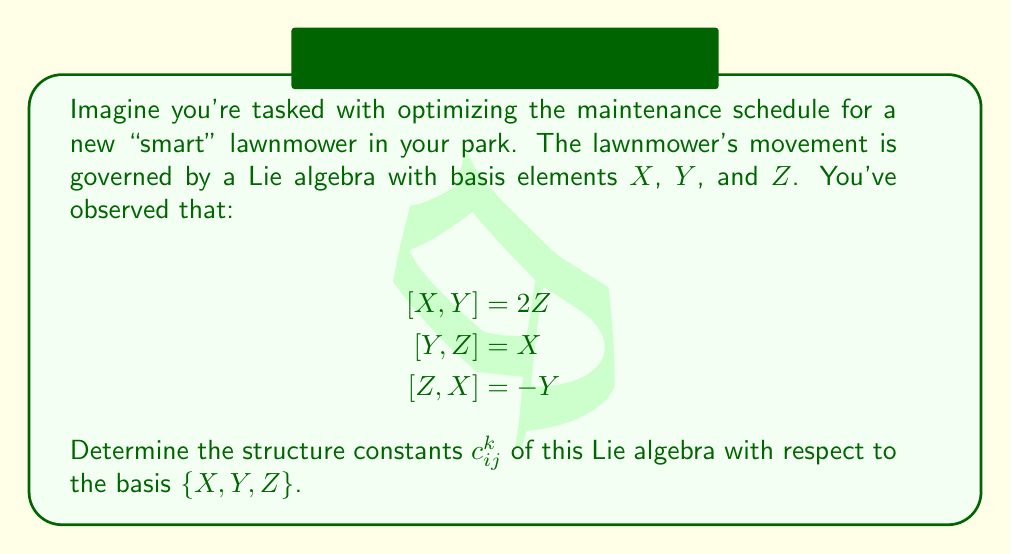Solve this math problem. To find the structure constants $c_{ij}^k$ of a Lie algebra, we need to express each Lie bracket $[X_i,X_j]$ as a linear combination of the basis elements:

$$[X_i,X_j] = \sum_{k} c_{ij}^k X_k$$

In this case, our basis is $\{X,Y,Z\}$, so we'll index them as $X_1 = X$, $X_2 = Y$, and $X_3 = Z$.

Let's analyze each given bracket:

1) $[X,Y] = 2Z$
   This means $[X_1,X_2] = 2X_3$, so $c_{12}^3 = 2$ (and $c_{12}^1 = c_{12}^2 = 0$)

2) $[Y,Z] = X$
   This means $[X_2,X_3] = X_1$, so $c_{23}^1 = 1$ (and $c_{23}^2 = c_{23}^3 = 0$)

3) $[Z,X] = -Y$
   This means $[X_3,X_1] = -X_2$, so $c_{31}^2 = -1$ (and $c_{31}^1 = c_{31}^3 = 0$)

Note that the structure constants are antisymmetric in the lower indices, meaning:
$$c_{ij}^k = -c_{ji}^k$$

So, we can also deduce:
$c_{21}^3 = -2$
$c_{32}^1 = -1$
$c_{13}^2 = 1$

All other structure constants are zero.
Answer: The non-zero structure constants are:
$$c_{12}^3 = 2, \quad c_{23}^1 = 1, \quad c_{31}^2 = -1$$
$$c_{21}^3 = -2, \quad c_{32}^1 = -1, \quad c_{13}^2 = 1$$
All other $c_{ij}^k = 0$. 